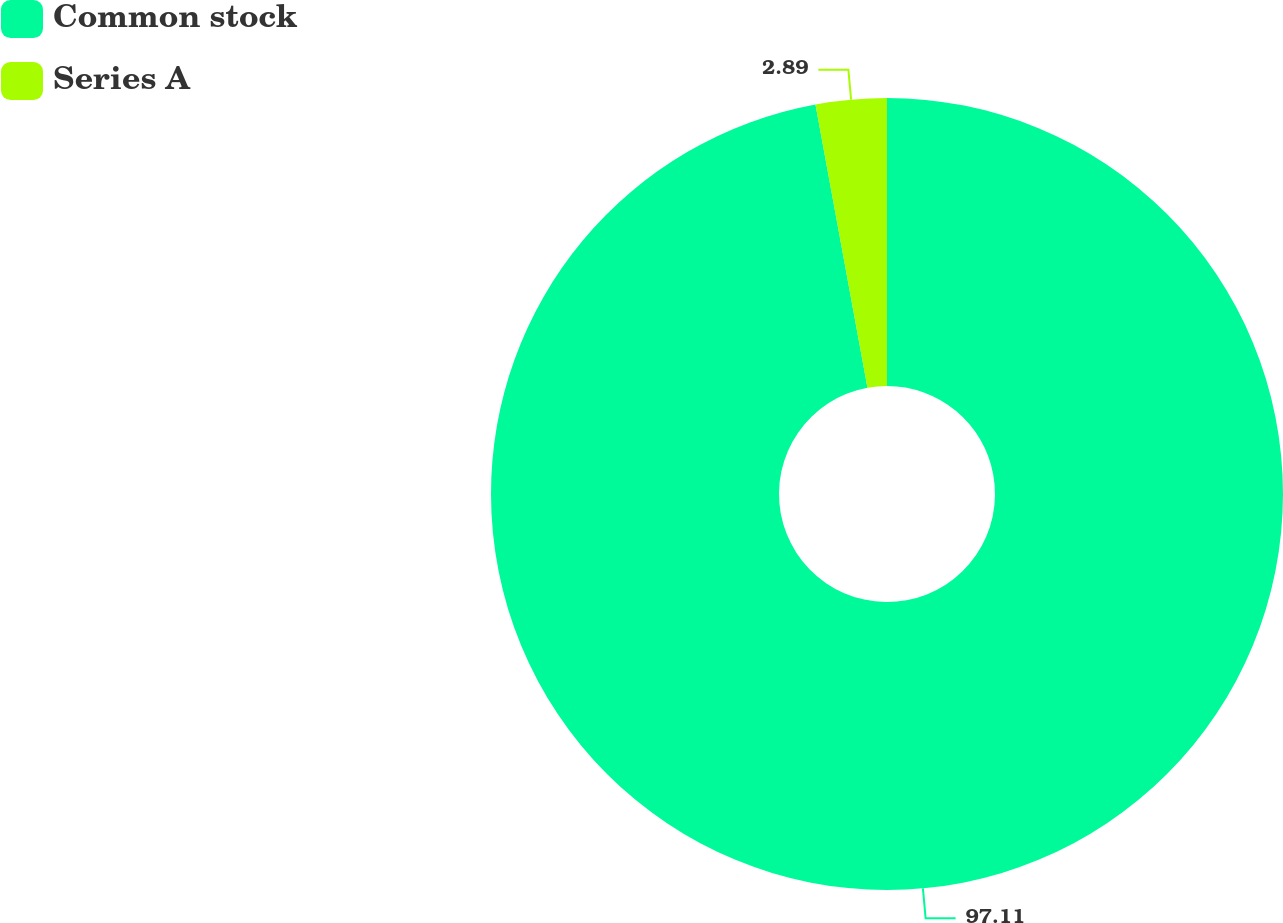Convert chart to OTSL. <chart><loc_0><loc_0><loc_500><loc_500><pie_chart><fcel>Common stock<fcel>Series A<nl><fcel>97.11%<fcel>2.89%<nl></chart> 